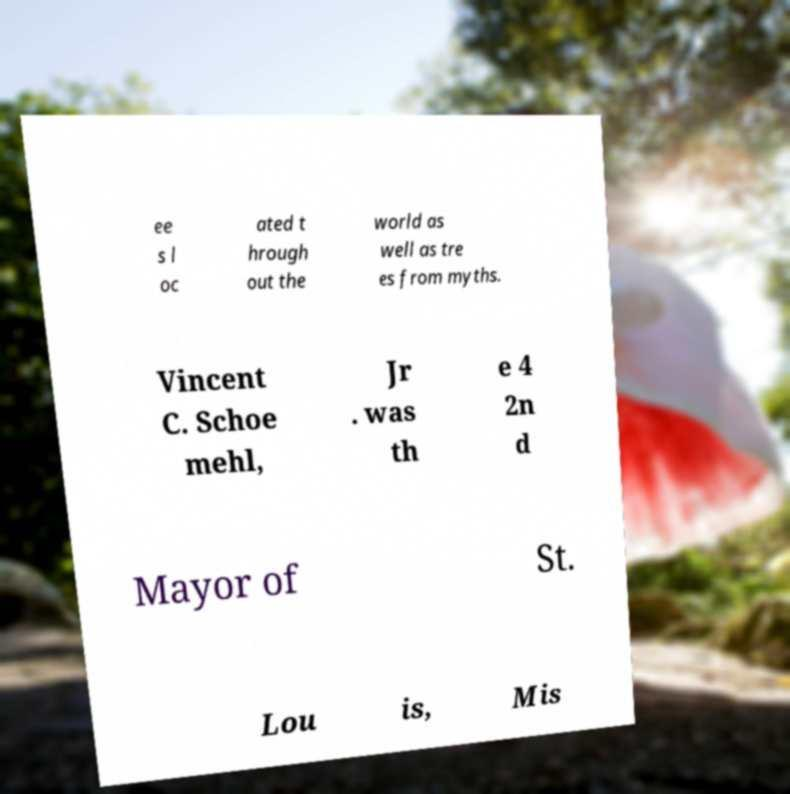Please identify and transcribe the text found in this image. ee s l oc ated t hrough out the world as well as tre es from myths. Vincent C. Schoe mehl, Jr . was th e 4 2n d Mayor of St. Lou is, Mis 